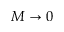<formula> <loc_0><loc_0><loc_500><loc_500>M \to 0</formula> 